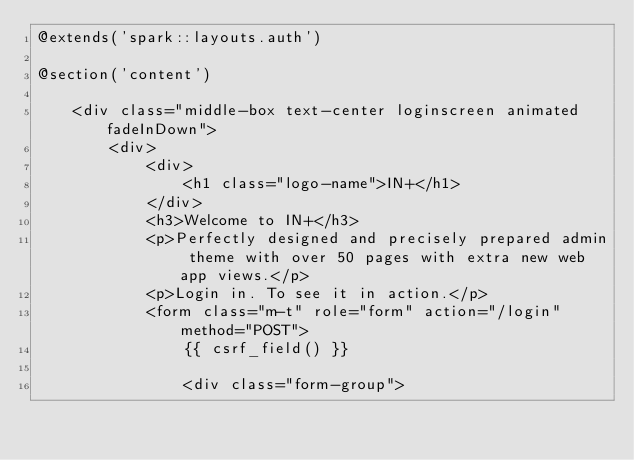<code> <loc_0><loc_0><loc_500><loc_500><_PHP_>@extends('spark::layouts.auth')

@section('content')

    <div class="middle-box text-center loginscreen animated fadeInDown">
        <div>
            <div>
                <h1 class="logo-name">IN+</h1>
            </div>
            <h3>Welcome to IN+</h3>
            <p>Perfectly designed and precisely prepared admin theme with over 50 pages with extra new web app views.</p>
            <p>Login in. To see it in action.</p>
            <form class="m-t" role="form" action="/login" method="POST">
                {{ csrf_field() }}

                <div class="form-group"></code> 